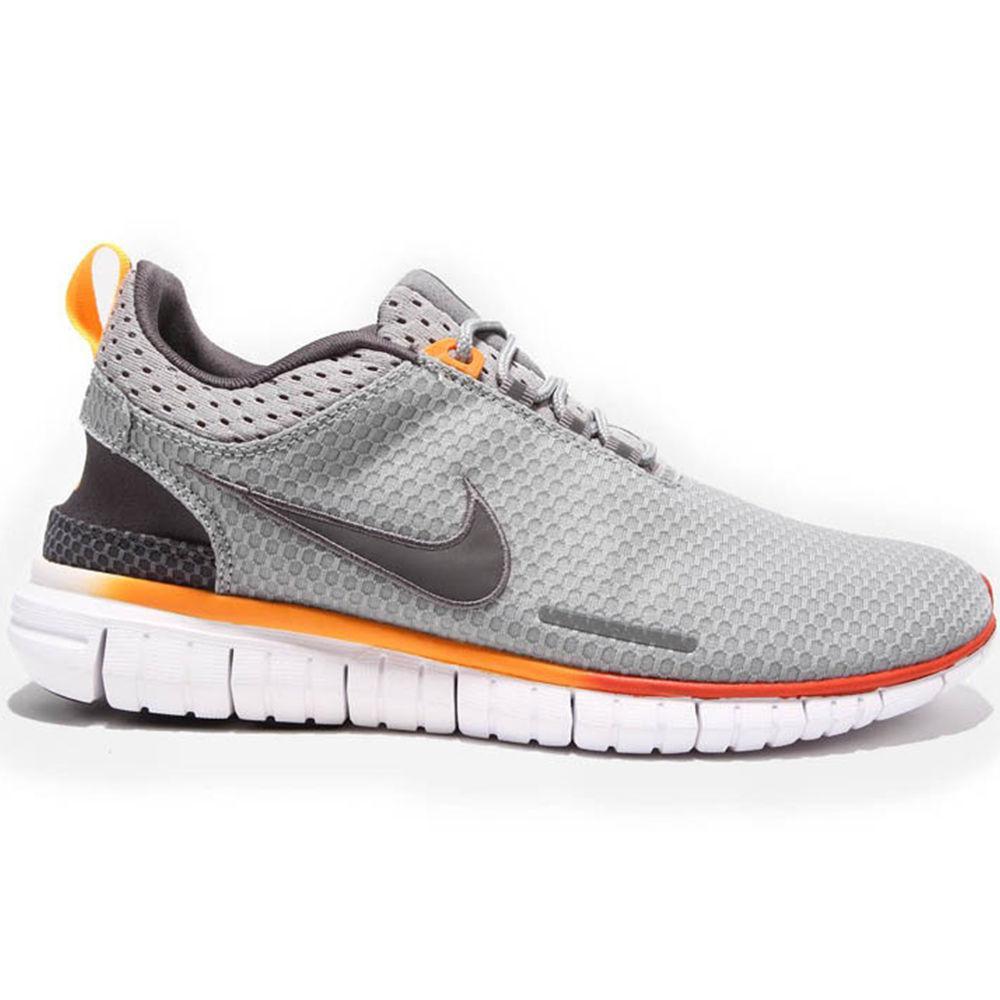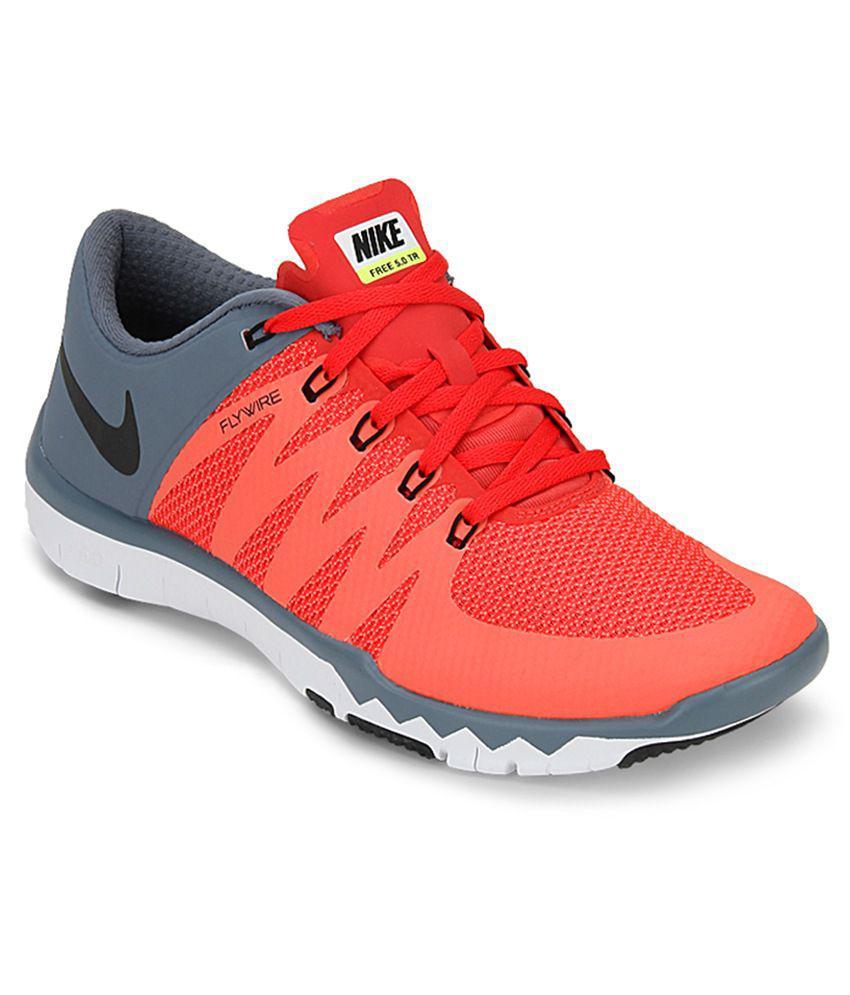The first image is the image on the left, the second image is the image on the right. For the images displayed, is the sentence "One image shows at least one black-laced shoe that is black with red and blue trim." factually correct? Answer yes or no. No. The first image is the image on the left, the second image is the image on the right. Considering the images on both sides, is "A shoe facing left has a lime green ribbon shape on it in one image." valid? Answer yes or no. No. 